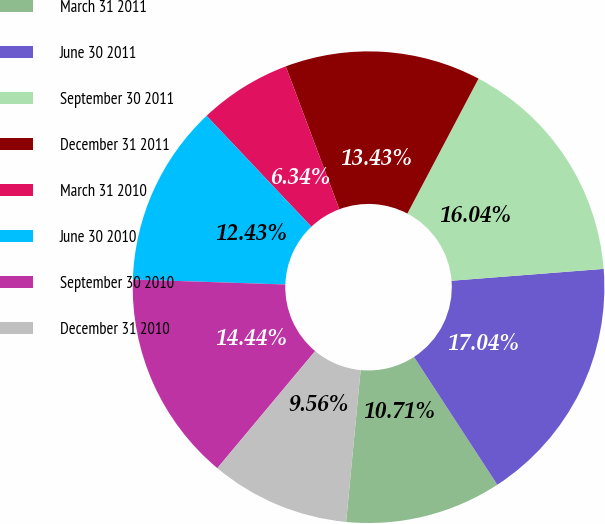Convert chart to OTSL. <chart><loc_0><loc_0><loc_500><loc_500><pie_chart><fcel>March 31 2011<fcel>June 30 2011<fcel>September 30 2011<fcel>December 31 2011<fcel>March 31 2010<fcel>June 30 2010<fcel>September 30 2010<fcel>December 31 2010<nl><fcel>10.71%<fcel>17.04%<fcel>16.04%<fcel>13.43%<fcel>6.34%<fcel>12.43%<fcel>14.44%<fcel>9.56%<nl></chart> 